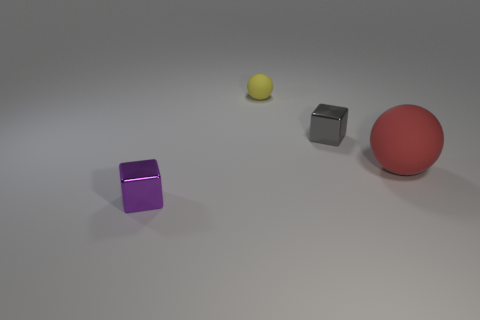What number of objects are both to the left of the small gray cube and in front of the gray thing?
Give a very brief answer. 1. There is a big ball that is behind the purple metal cube that is in front of the big red matte thing; what is its material?
Ensure brevity in your answer.  Rubber. What material is the tiny yellow object that is the same shape as the red rubber thing?
Provide a succinct answer. Rubber. Are any tiny blue rubber blocks visible?
Keep it short and to the point. No. There is a small purple thing that is the same material as the gray cube; what shape is it?
Your answer should be compact. Cube. What material is the cube in front of the gray thing?
Provide a succinct answer. Metal. What size is the cube to the left of the rubber sphere behind the tiny gray metal object?
Offer a terse response. Small. Is the number of tiny yellow objects on the left side of the large red matte object greater than the number of gray rubber spheres?
Your response must be concise. Yes. Do the block that is in front of the red object and the yellow matte object have the same size?
Your answer should be compact. Yes. There is a object that is behind the big thing and in front of the tiny yellow matte sphere; what color is it?
Offer a terse response. Gray. 